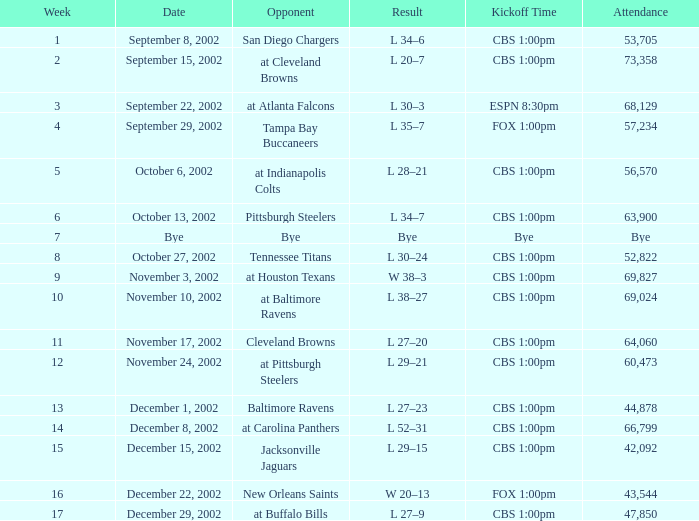What week was the opponent the San Diego Chargers? 1.0. 